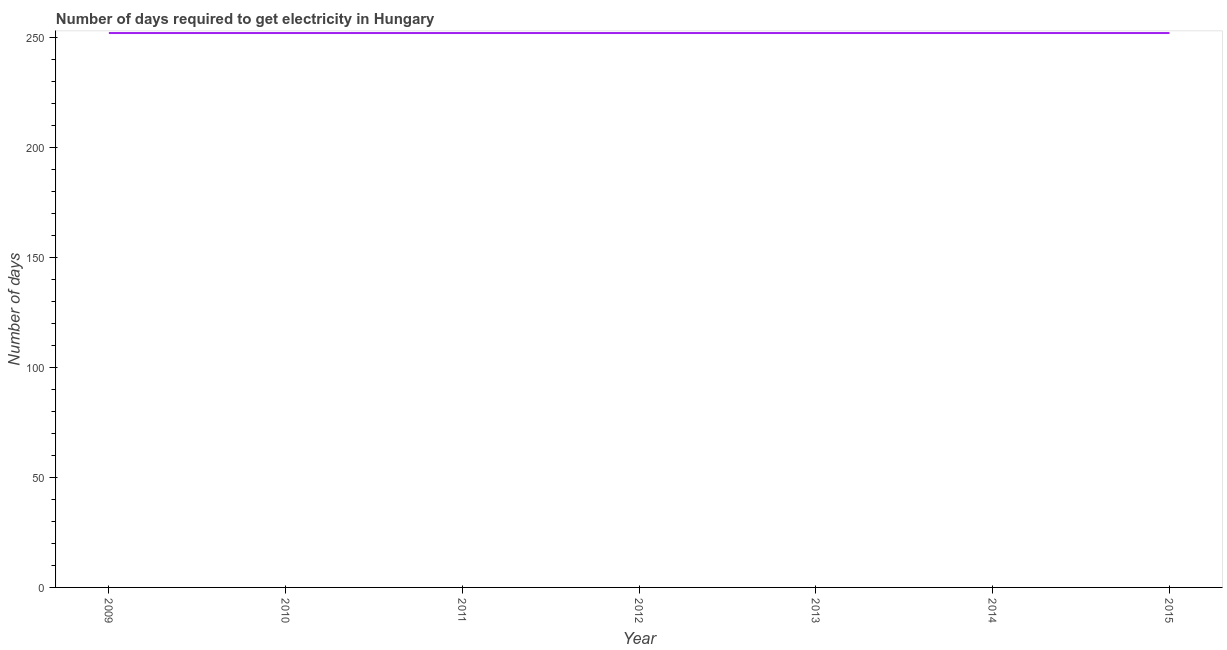What is the time to get electricity in 2015?
Your answer should be very brief. 252. Across all years, what is the maximum time to get electricity?
Ensure brevity in your answer.  252. Across all years, what is the minimum time to get electricity?
Provide a succinct answer. 252. In which year was the time to get electricity maximum?
Offer a terse response. 2009. What is the sum of the time to get electricity?
Make the answer very short. 1764. What is the average time to get electricity per year?
Provide a succinct answer. 252. What is the median time to get electricity?
Your answer should be very brief. 252. In how many years, is the time to get electricity greater than 190 ?
Provide a short and direct response. 7. What is the difference between the highest and the second highest time to get electricity?
Your response must be concise. 0. Is the sum of the time to get electricity in 2009 and 2011 greater than the maximum time to get electricity across all years?
Provide a succinct answer. Yes. What is the difference between the highest and the lowest time to get electricity?
Your answer should be compact. 0. How many lines are there?
Offer a terse response. 1. Are the values on the major ticks of Y-axis written in scientific E-notation?
Provide a succinct answer. No. Does the graph contain grids?
Give a very brief answer. No. What is the title of the graph?
Your answer should be compact. Number of days required to get electricity in Hungary. What is the label or title of the X-axis?
Provide a short and direct response. Year. What is the label or title of the Y-axis?
Your response must be concise. Number of days. What is the Number of days in 2009?
Give a very brief answer. 252. What is the Number of days in 2010?
Offer a very short reply. 252. What is the Number of days of 2011?
Provide a short and direct response. 252. What is the Number of days of 2012?
Provide a succinct answer. 252. What is the Number of days of 2013?
Your answer should be compact. 252. What is the Number of days of 2014?
Your answer should be very brief. 252. What is the Number of days of 2015?
Give a very brief answer. 252. What is the difference between the Number of days in 2009 and 2010?
Make the answer very short. 0. What is the difference between the Number of days in 2009 and 2011?
Offer a terse response. 0. What is the difference between the Number of days in 2009 and 2012?
Your answer should be very brief. 0. What is the difference between the Number of days in 2010 and 2012?
Keep it short and to the point. 0. What is the difference between the Number of days in 2010 and 2015?
Provide a short and direct response. 0. What is the difference between the Number of days in 2011 and 2014?
Offer a terse response. 0. What is the difference between the Number of days in 2011 and 2015?
Ensure brevity in your answer.  0. What is the difference between the Number of days in 2013 and 2014?
Make the answer very short. 0. What is the difference between the Number of days in 2013 and 2015?
Give a very brief answer. 0. What is the difference between the Number of days in 2014 and 2015?
Ensure brevity in your answer.  0. What is the ratio of the Number of days in 2009 to that in 2013?
Provide a short and direct response. 1. What is the ratio of the Number of days in 2009 to that in 2015?
Your answer should be compact. 1. What is the ratio of the Number of days in 2010 to that in 2011?
Offer a very short reply. 1. What is the ratio of the Number of days in 2010 to that in 2014?
Your answer should be very brief. 1. What is the ratio of the Number of days in 2010 to that in 2015?
Your response must be concise. 1. What is the ratio of the Number of days in 2011 to that in 2015?
Provide a short and direct response. 1. What is the ratio of the Number of days in 2012 to that in 2014?
Your answer should be very brief. 1. What is the ratio of the Number of days in 2012 to that in 2015?
Keep it short and to the point. 1. What is the ratio of the Number of days in 2013 to that in 2014?
Keep it short and to the point. 1. 